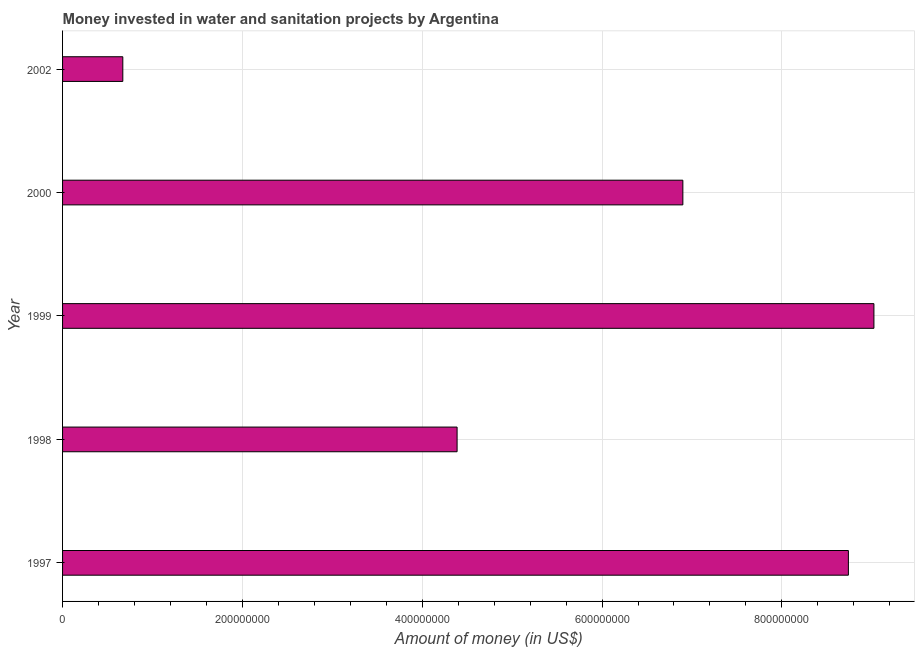What is the title of the graph?
Make the answer very short. Money invested in water and sanitation projects by Argentina. What is the label or title of the X-axis?
Give a very brief answer. Amount of money (in US$). What is the label or title of the Y-axis?
Ensure brevity in your answer.  Year. What is the investment in 1998?
Offer a very short reply. 4.39e+08. Across all years, what is the maximum investment?
Make the answer very short. 9.02e+08. Across all years, what is the minimum investment?
Make the answer very short. 6.70e+07. In which year was the investment minimum?
Offer a terse response. 2002. What is the sum of the investment?
Provide a short and direct response. 2.97e+09. What is the difference between the investment in 1997 and 1998?
Offer a terse response. 4.35e+08. What is the average investment per year?
Provide a short and direct response. 5.94e+08. What is the median investment?
Provide a short and direct response. 6.90e+08. Do a majority of the years between 2002 and 1997 (inclusive) have investment greater than 800000000 US$?
Your response must be concise. Yes. What is the ratio of the investment in 1997 to that in 2000?
Your answer should be very brief. 1.27. What is the difference between the highest and the second highest investment?
Keep it short and to the point. 2.84e+07. Is the sum of the investment in 1999 and 2000 greater than the maximum investment across all years?
Give a very brief answer. Yes. What is the difference between the highest and the lowest investment?
Your answer should be compact. 8.35e+08. How many bars are there?
Ensure brevity in your answer.  5. Are all the bars in the graph horizontal?
Provide a short and direct response. Yes. What is the difference between two consecutive major ticks on the X-axis?
Your response must be concise. 2.00e+08. Are the values on the major ticks of X-axis written in scientific E-notation?
Make the answer very short. No. What is the Amount of money (in US$) of 1997?
Provide a succinct answer. 8.74e+08. What is the Amount of money (in US$) of 1998?
Offer a very short reply. 4.39e+08. What is the Amount of money (in US$) in 1999?
Make the answer very short. 9.02e+08. What is the Amount of money (in US$) of 2000?
Offer a terse response. 6.90e+08. What is the Amount of money (in US$) in 2002?
Keep it short and to the point. 6.70e+07. What is the difference between the Amount of money (in US$) in 1997 and 1998?
Ensure brevity in your answer.  4.35e+08. What is the difference between the Amount of money (in US$) in 1997 and 1999?
Your answer should be very brief. -2.84e+07. What is the difference between the Amount of money (in US$) in 1997 and 2000?
Keep it short and to the point. 1.84e+08. What is the difference between the Amount of money (in US$) in 1997 and 2002?
Your answer should be very brief. 8.07e+08. What is the difference between the Amount of money (in US$) in 1998 and 1999?
Provide a short and direct response. -4.64e+08. What is the difference between the Amount of money (in US$) in 1998 and 2000?
Your response must be concise. -2.51e+08. What is the difference between the Amount of money (in US$) in 1998 and 2002?
Ensure brevity in your answer.  3.72e+08. What is the difference between the Amount of money (in US$) in 1999 and 2000?
Provide a succinct answer. 2.12e+08. What is the difference between the Amount of money (in US$) in 1999 and 2002?
Keep it short and to the point. 8.35e+08. What is the difference between the Amount of money (in US$) in 2000 and 2002?
Ensure brevity in your answer.  6.23e+08. What is the ratio of the Amount of money (in US$) in 1997 to that in 1998?
Give a very brief answer. 1.99. What is the ratio of the Amount of money (in US$) in 1997 to that in 2000?
Your answer should be compact. 1.27. What is the ratio of the Amount of money (in US$) in 1997 to that in 2002?
Provide a short and direct response. 13.04. What is the ratio of the Amount of money (in US$) in 1998 to that in 1999?
Your answer should be compact. 0.49. What is the ratio of the Amount of money (in US$) in 1998 to that in 2000?
Make the answer very short. 0.64. What is the ratio of the Amount of money (in US$) in 1998 to that in 2002?
Provide a succinct answer. 6.55. What is the ratio of the Amount of money (in US$) in 1999 to that in 2000?
Your answer should be very brief. 1.31. What is the ratio of the Amount of money (in US$) in 1999 to that in 2002?
Make the answer very short. 13.47. What is the ratio of the Amount of money (in US$) in 2000 to that in 2002?
Provide a succinct answer. 10.3. 